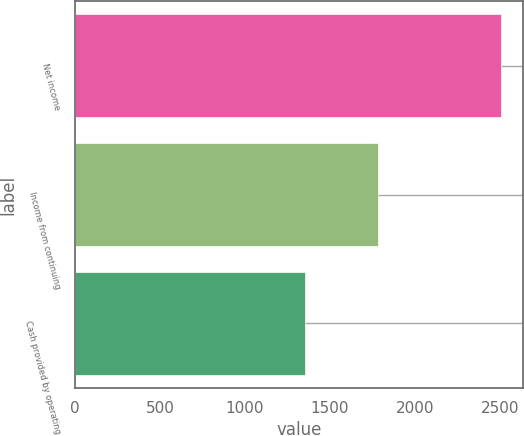Convert chart. <chart><loc_0><loc_0><loc_500><loc_500><bar_chart><fcel>Net income<fcel>Income from continuing<fcel>Cash provided by operating<nl><fcel>2508<fcel>1782<fcel>1353<nl></chart> 